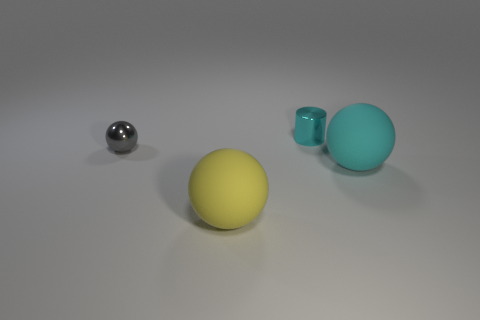Subtract 1 spheres. How many spheres are left? 2 Subtract all big spheres. How many spheres are left? 1 Add 3 cyan matte objects. How many objects exist? 7 Add 3 small gray cubes. How many small gray cubes exist? 3 Subtract 0 gray cubes. How many objects are left? 4 Subtract all spheres. How many objects are left? 1 Subtract all small gray metal things. Subtract all small gray balls. How many objects are left? 2 Add 2 tiny cyan objects. How many tiny cyan objects are left? 3 